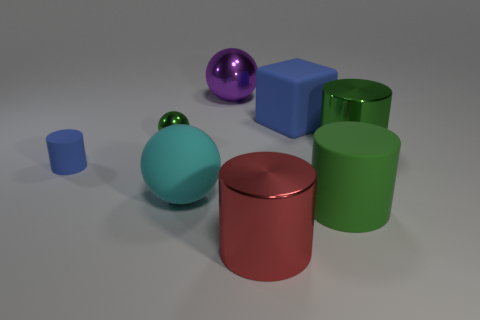Subtract all tiny blue rubber cylinders. How many cylinders are left? 3 Subtract all cyan cubes. How many green cylinders are left? 2 Subtract 1 cylinders. How many cylinders are left? 3 Subtract all red cylinders. How many cylinders are left? 3 Add 1 big green matte cylinders. How many objects exist? 9 Subtract all cubes. How many objects are left? 7 Add 3 large purple shiny things. How many large purple shiny things exist? 4 Subtract 1 red cylinders. How many objects are left? 7 Subtract all red cylinders. Subtract all green balls. How many cylinders are left? 3 Subtract all small green cylinders. Subtract all tiny green metal spheres. How many objects are left? 7 